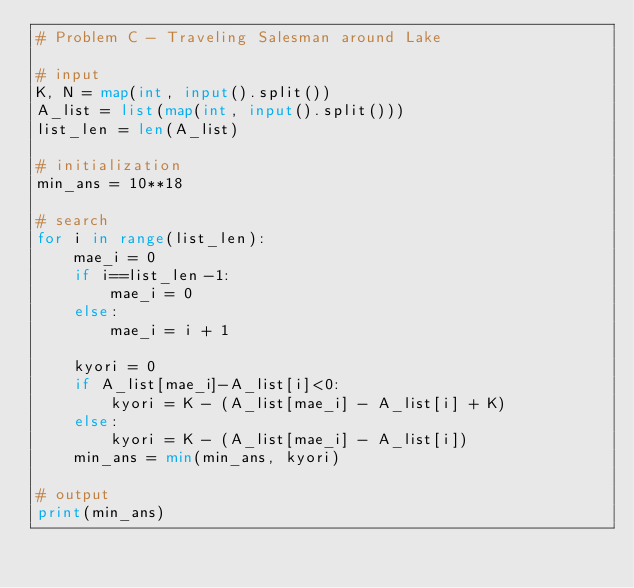<code> <loc_0><loc_0><loc_500><loc_500><_Python_># Problem C - Traveling Salesman around Lake

# input
K, N = map(int, input().split())
A_list = list(map(int, input().split()))
list_len = len(A_list)

# initialization
min_ans = 10**18

# search
for i in range(list_len):
    mae_i = 0
    if i==list_len-1:
        mae_i = 0
    else:
        mae_i = i + 1

    kyori = 0
    if A_list[mae_i]-A_list[i]<0:
        kyori = K - (A_list[mae_i] - A_list[i] + K)
    else:
        kyori = K - (A_list[mae_i] - A_list[i])
    min_ans = min(min_ans, kyori)

# output
print(min_ans)
</code> 